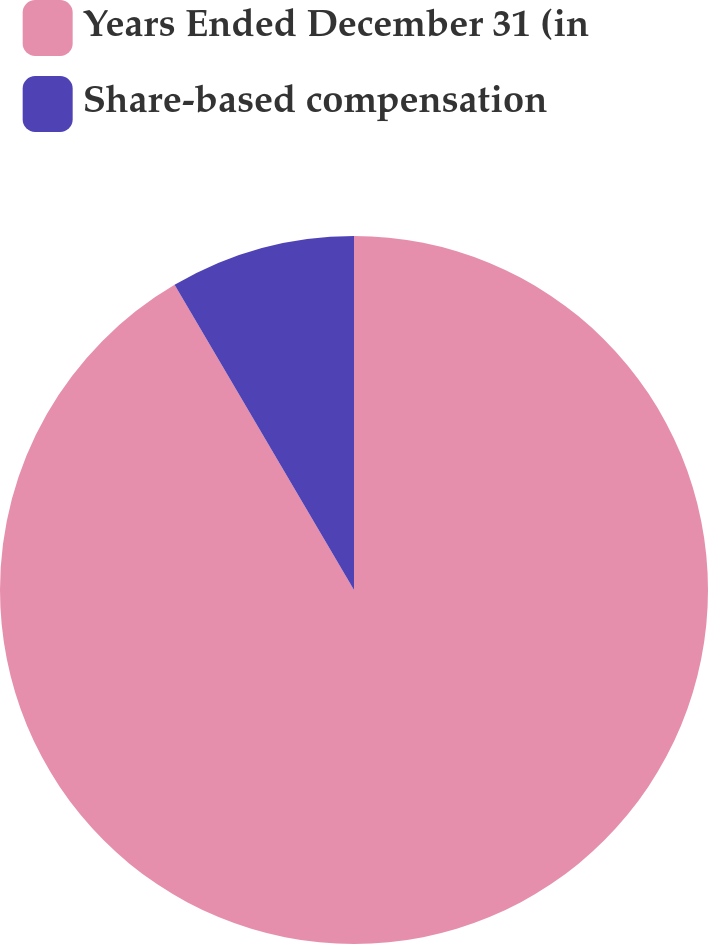Convert chart to OTSL. <chart><loc_0><loc_0><loc_500><loc_500><pie_chart><fcel>Years Ended December 31 (in<fcel>Share-based compensation<nl><fcel>91.54%<fcel>8.46%<nl></chart> 